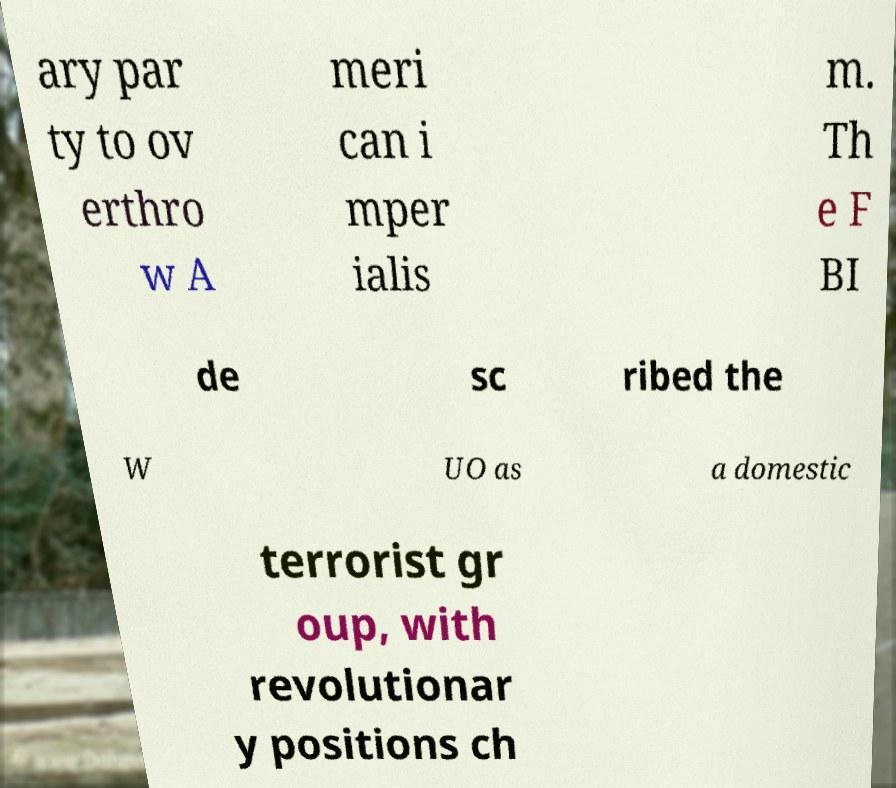Could you extract and type out the text from this image? ary par ty to ov erthro w A meri can i mper ialis m. Th e F BI de sc ribed the W UO as a domestic terrorist gr oup, with revolutionar y positions ch 